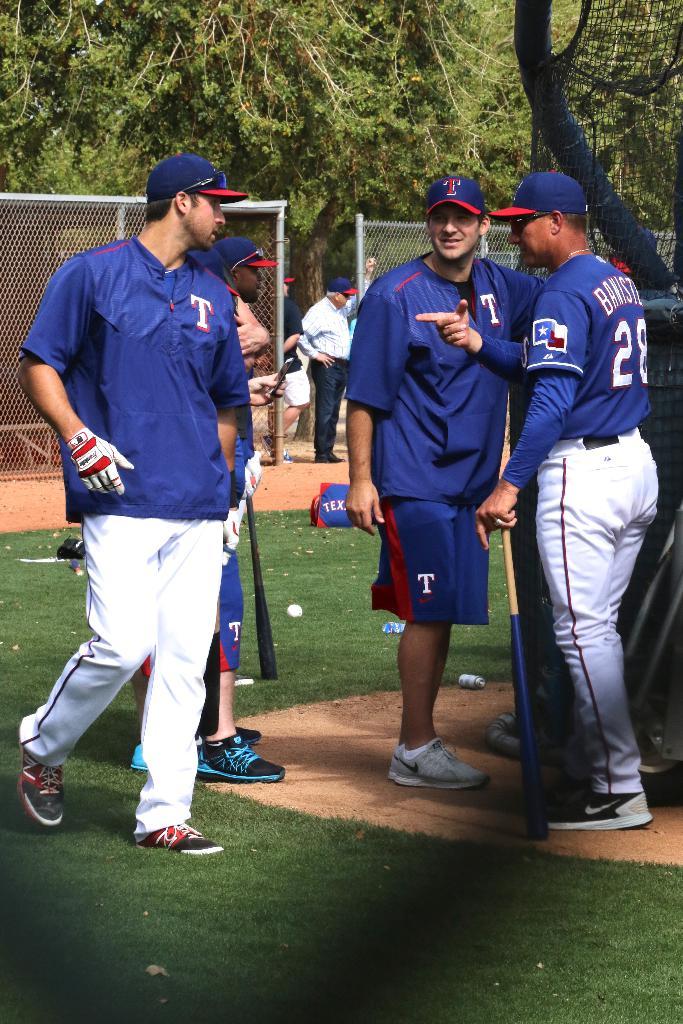What number is the player on the right?
Ensure brevity in your answer.  28. What is the color of their jerseys?
Offer a terse response. Answering does not require reading text in the image. 